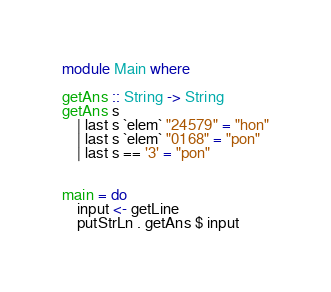<code> <loc_0><loc_0><loc_500><loc_500><_Haskell_>module Main where

getAns :: String -> String
getAns s
	| last s `elem` "24579" = "hon"
	| last s `elem` "0168" = "pon"
	| last s == '3' = "pon"


main = do
	input <- getLine
	putStrLn . getAns $ input

</code> 